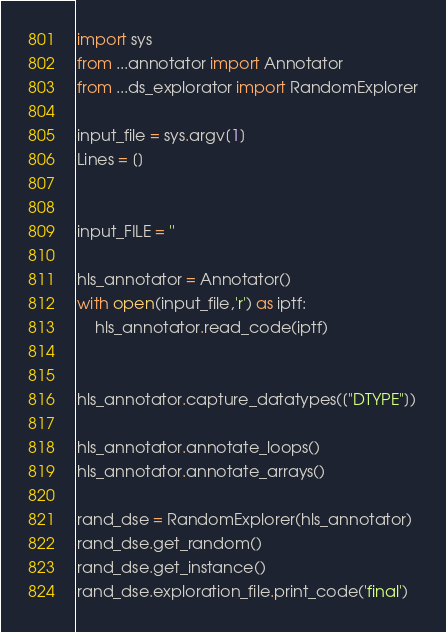<code> <loc_0><loc_0><loc_500><loc_500><_Python_>import sys
from ...annotator import Annotator
from ...ds_explorator import RandomExplorer

input_file = sys.argv[1]
Lines = []


input_FILE = ''

hls_annotator = Annotator()
with open(input_file,'r') as iptf:
    hls_annotator.read_code(iptf)


hls_annotator.capture_datatypes(["DTYPE"])

hls_annotator.annotate_loops()
hls_annotator.annotate_arrays()

rand_dse = RandomExplorer(hls_annotator)
rand_dse.get_random()
rand_dse.get_instance()
rand_dse.exploration_file.print_code('final')
</code> 